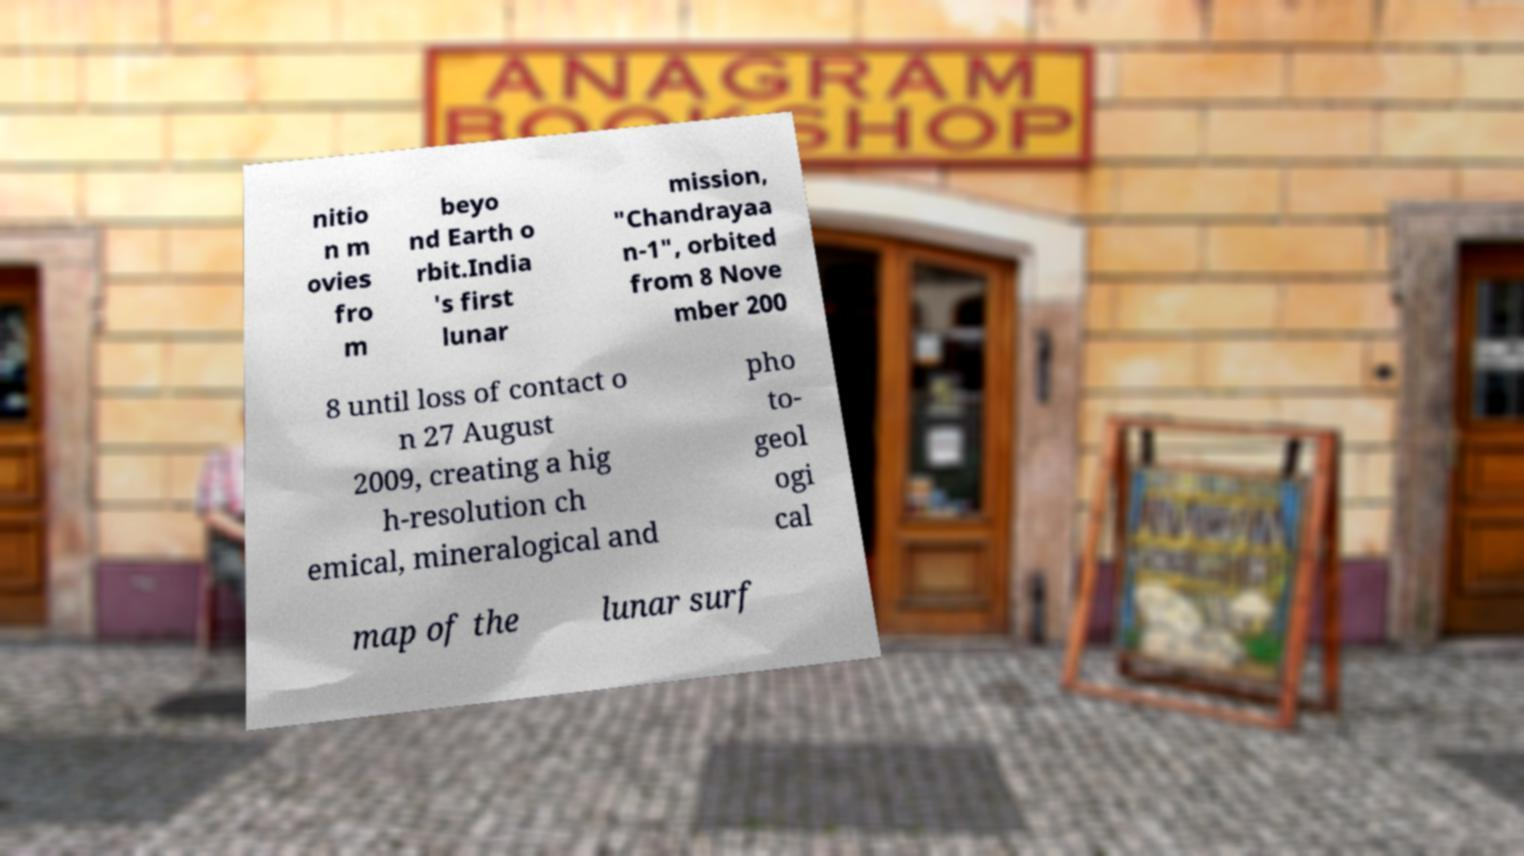What messages or text are displayed in this image? I need them in a readable, typed format. nitio n m ovies fro m beyo nd Earth o rbit.India 's first lunar mission, "Chandrayaa n-1", orbited from 8 Nove mber 200 8 until loss of contact o n 27 August 2009, creating a hig h-resolution ch emical, mineralogical and pho to- geol ogi cal map of the lunar surf 